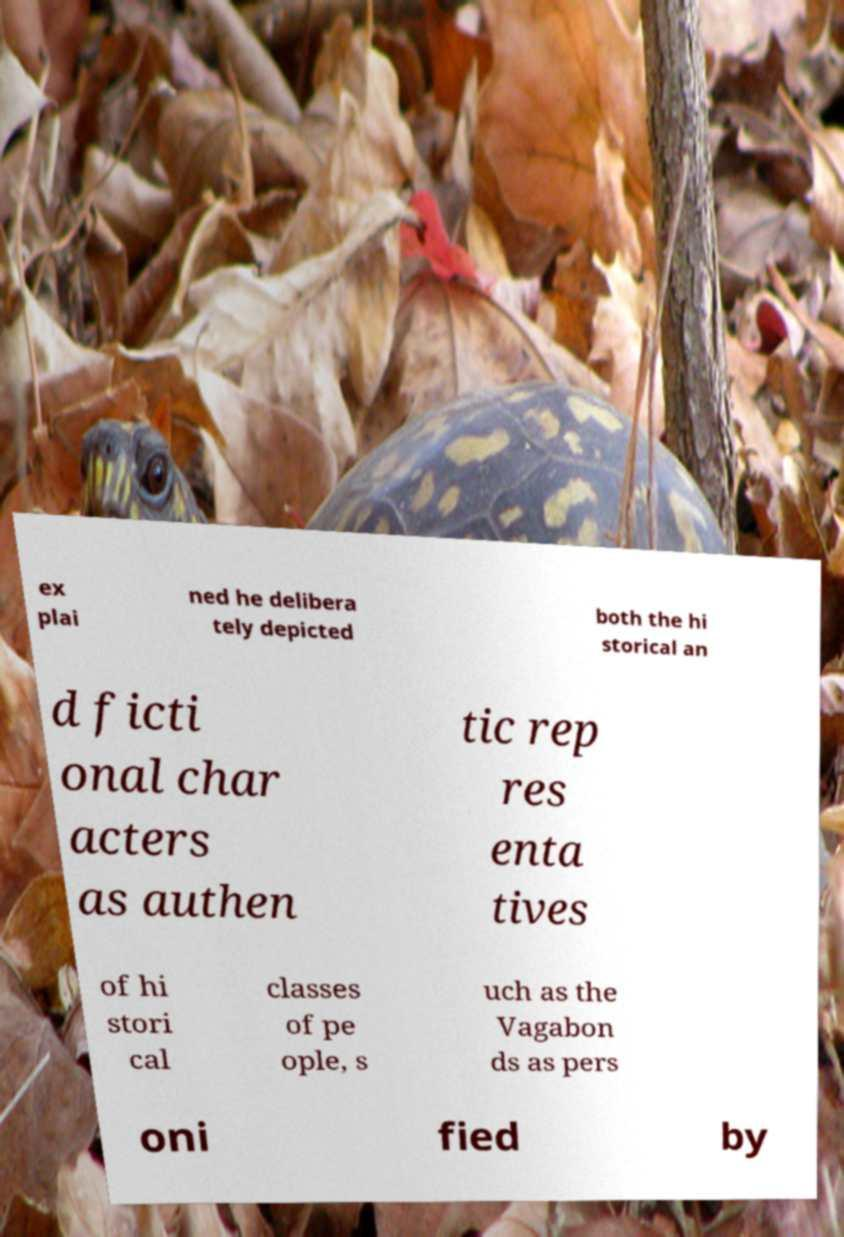For documentation purposes, I need the text within this image transcribed. Could you provide that? ex plai ned he delibera tely depicted both the hi storical an d ficti onal char acters as authen tic rep res enta tives of hi stori cal classes of pe ople, s uch as the Vagabon ds as pers oni fied by 